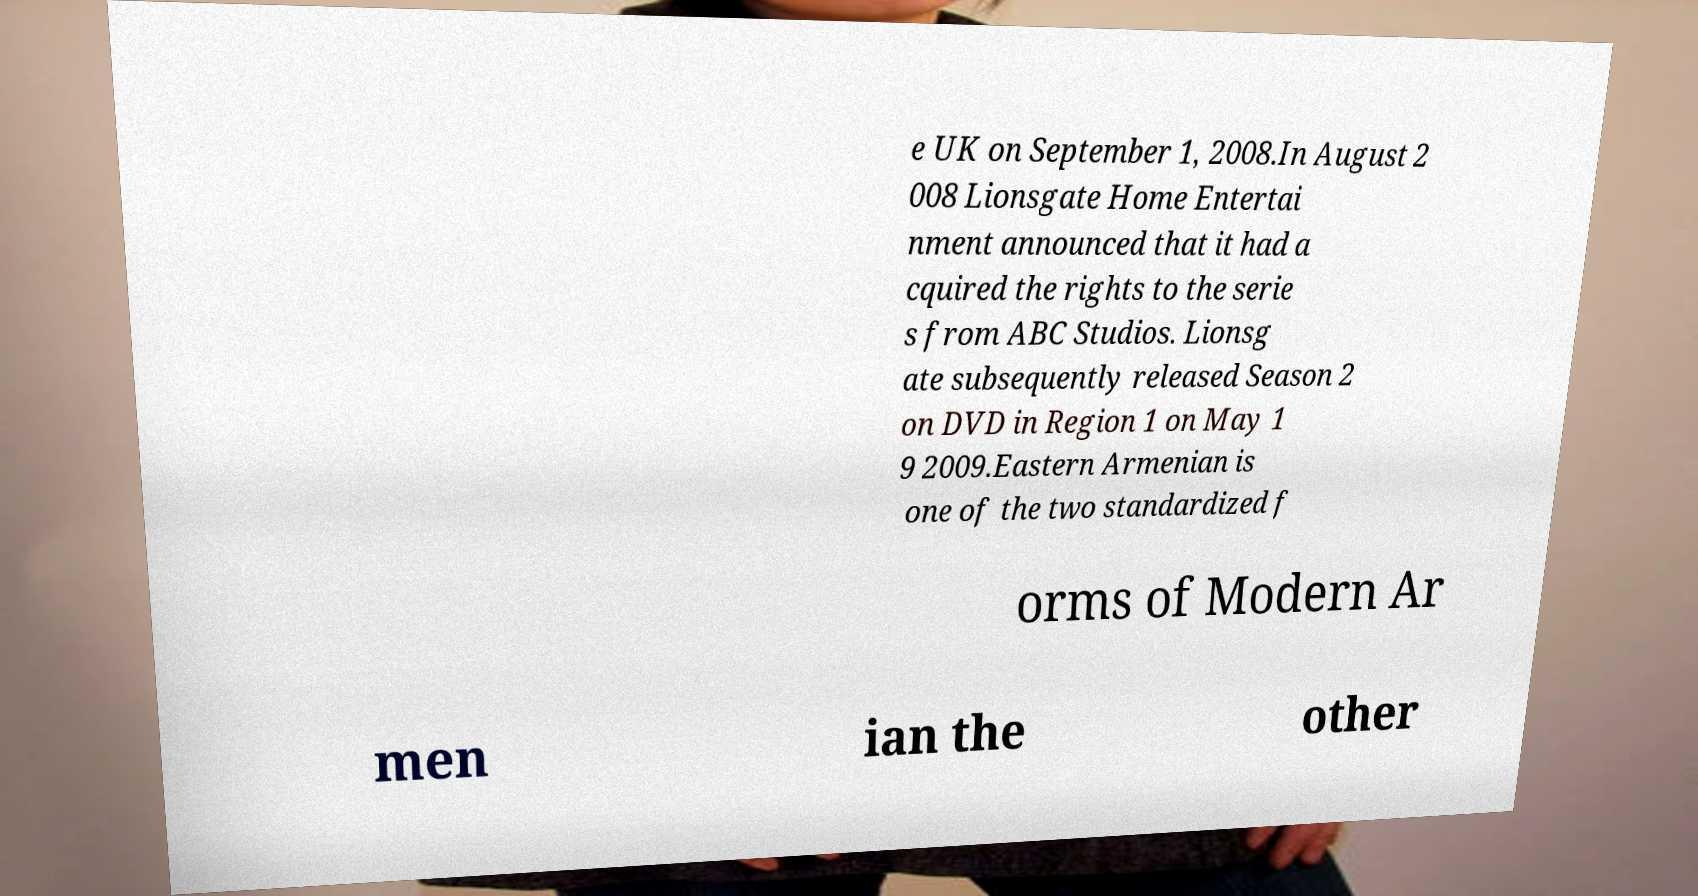What messages or text are displayed in this image? I need them in a readable, typed format. e UK on September 1, 2008.In August 2 008 Lionsgate Home Entertai nment announced that it had a cquired the rights to the serie s from ABC Studios. Lionsg ate subsequently released Season 2 on DVD in Region 1 on May 1 9 2009.Eastern Armenian is one of the two standardized f orms of Modern Ar men ian the other 